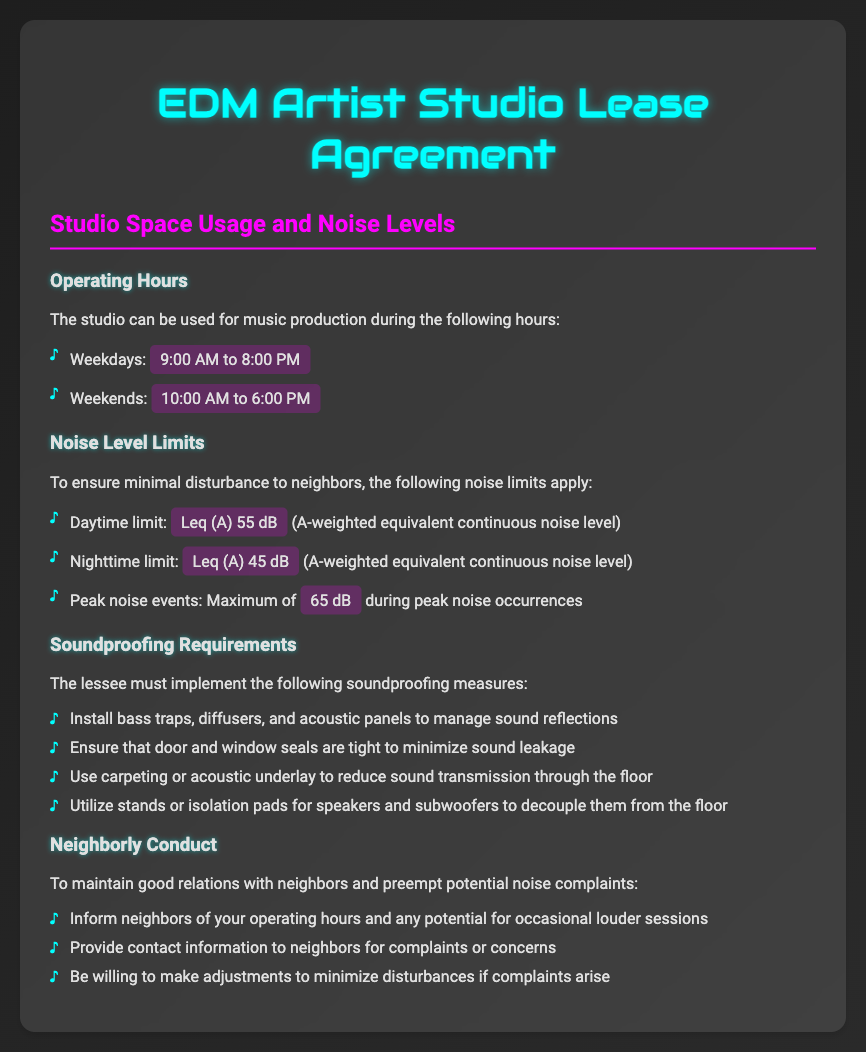What are the weekday operating hours? The document states the operating hours on weekdays are from 9:00 AM to 8:00 PM.
Answer: 9:00 AM to 8:00 PM What is the nighttime noise limit in dB? The document specifies the nighttime noise limit as Leq (A) 45 dB.
Answer: Leq (A) 45 dB What soundproofing measure must be implemented? The document lists the requirement to install bass traps, diffusers, and acoustic panels.
Answer: Install bass traps, diffusers, and acoustic panels What is the peak noise level during events? The document indicates that the maximum peak noise level is 65 dB during peak noise occurrences.
Answer: 65 dB What is suggested to maintain good relations with neighbors? The document states that informing neighbors of operating hours is recommended for neighborly conduct.
Answer: Inform neighbors of your operating hours What is the acceptable daytime noise limit? The document specifies the daytime noise limit as Leq (A) 55 dB.
Answer: Leq (A) 55 dB What type of noise level measurement is referenced? The document uses the term “A-weighted equivalent continuous noise level” to refer to noise measurements.
Answer: A-weighted equivalent continuous noise level What type of flooring is encouraged to reduce sound transmission? The document suggests using carpeting or acoustic underlay to minimize sound transmission.
Answer: Carpeting or acoustic underlay What are the weekend operating hours? According to the document, the operating hours on weekends are from 10:00 AM to 6:00 PM.
Answer: 10:00 AM to 6:00 PM 